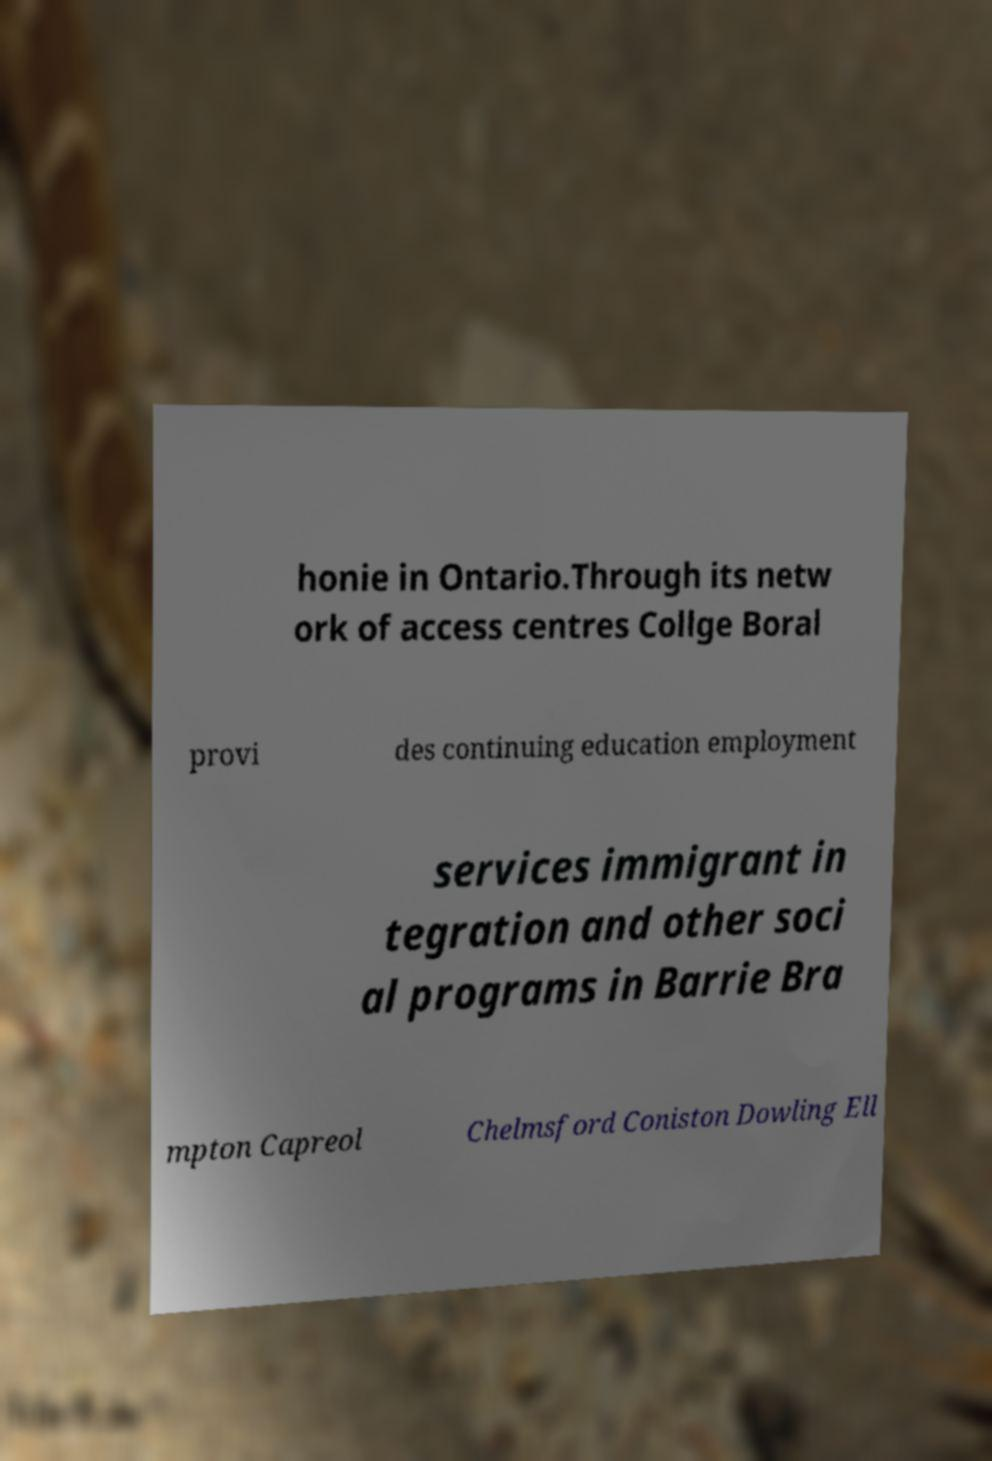Can you accurately transcribe the text from the provided image for me? honie in Ontario.Through its netw ork of access centres Collge Boral provi des continuing education employment services immigrant in tegration and other soci al programs in Barrie Bra mpton Capreol Chelmsford Coniston Dowling Ell 